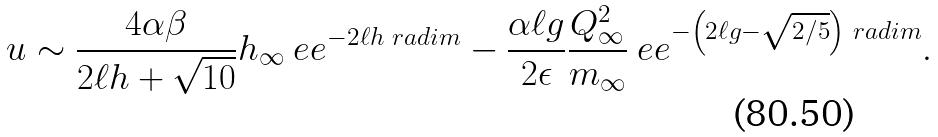Convert formula to latex. <formula><loc_0><loc_0><loc_500><loc_500>u \sim \frac { 4 \alpha \beta } { 2 \ell h + \sqrt { 1 0 } } h _ { \infty } \ e e ^ { - 2 \ell h \ r a d i m } - \frac { \alpha \ell g } { 2 \epsilon } \frac { Q _ { \infty } ^ { 2 } } { m _ { \infty } } \ e e ^ { - \left ( 2 \ell g - \sqrt { 2 / 5 } \right ) \ r a d i m } .</formula> 